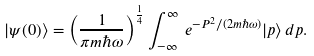Convert formula to latex. <formula><loc_0><loc_0><loc_500><loc_500>| \psi ( 0 ) \rangle = \left ( \frac { 1 } { \pi m \hbar { \omega } } \right ) ^ { \frac { 1 } { 4 } } \int _ { - \infty } ^ { \infty } \, e ^ { - P ^ { 2 } / ( 2 m \hbar { \omega } ) } | p \rangle \, d p .</formula> 